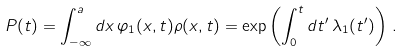Convert formula to latex. <formula><loc_0><loc_0><loc_500><loc_500>P ( t ) = \int _ { - \infty } ^ { a } d x \, \varphi _ { 1 } ( x , t ) \rho ( x , t ) = \exp \left ( \int _ { 0 } ^ { t } d t ^ { \prime } \, \lambda _ { 1 } ( t ^ { \prime } ) \right ) \, .</formula> 